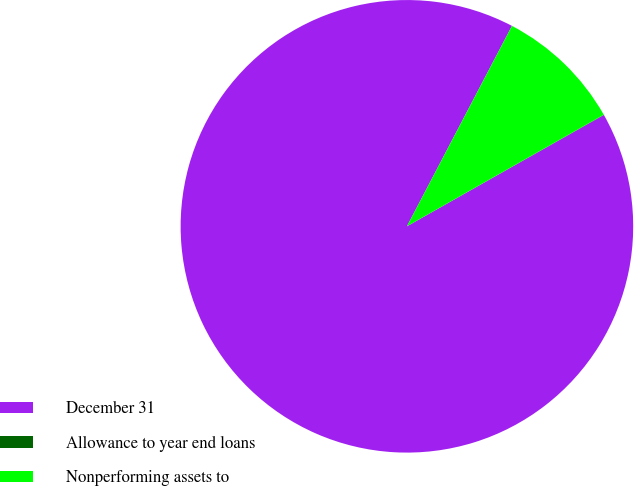<chart> <loc_0><loc_0><loc_500><loc_500><pie_chart><fcel>December 31<fcel>Allowance to year end loans<fcel>Nonperforming assets to<nl><fcel>90.87%<fcel>0.02%<fcel>9.11%<nl></chart> 